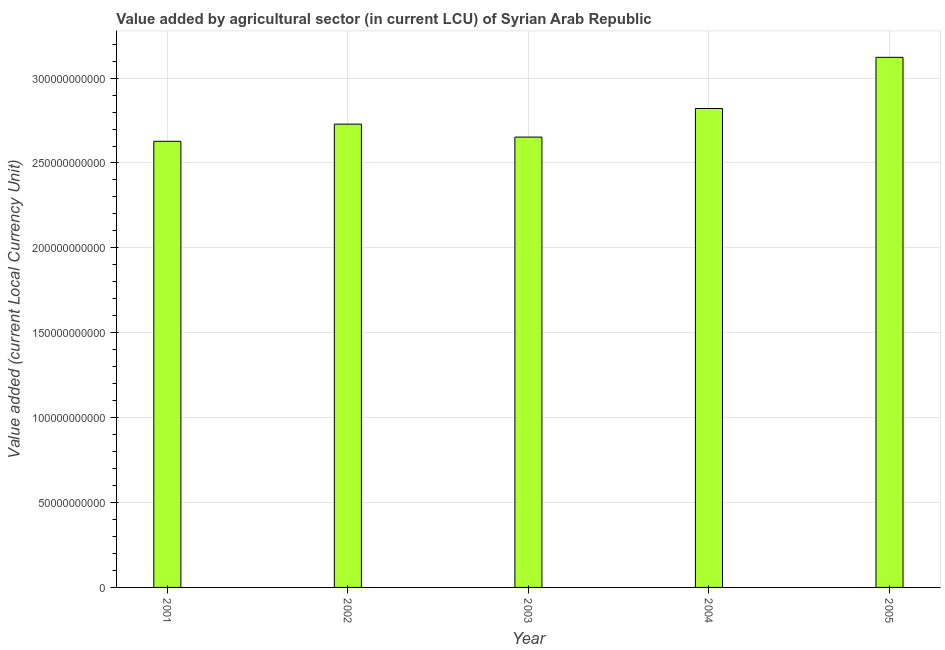Does the graph contain any zero values?
Provide a short and direct response. No. What is the title of the graph?
Give a very brief answer. Value added by agricultural sector (in current LCU) of Syrian Arab Republic. What is the label or title of the Y-axis?
Make the answer very short. Value added (current Local Currency Unit). What is the value added by agriculture sector in 2004?
Offer a terse response. 2.82e+11. Across all years, what is the maximum value added by agriculture sector?
Give a very brief answer. 3.12e+11. Across all years, what is the minimum value added by agriculture sector?
Offer a very short reply. 2.63e+11. What is the sum of the value added by agriculture sector?
Give a very brief answer. 1.40e+12. What is the difference between the value added by agriculture sector in 2001 and 2005?
Provide a short and direct response. -4.95e+1. What is the average value added by agriculture sector per year?
Your answer should be compact. 2.79e+11. What is the median value added by agriculture sector?
Make the answer very short. 2.73e+11. Do a majority of the years between 2003 and 2005 (inclusive) have value added by agriculture sector greater than 310000000000 LCU?
Provide a short and direct response. No. Is the difference between the value added by agriculture sector in 2001 and 2005 greater than the difference between any two years?
Your answer should be very brief. Yes. What is the difference between the highest and the second highest value added by agriculture sector?
Provide a succinct answer. 3.01e+1. What is the difference between the highest and the lowest value added by agriculture sector?
Offer a very short reply. 4.95e+1. How many bars are there?
Ensure brevity in your answer.  5. How many years are there in the graph?
Your answer should be very brief. 5. What is the Value added (current Local Currency Unit) of 2001?
Your response must be concise. 2.63e+11. What is the Value added (current Local Currency Unit) in 2002?
Offer a very short reply. 2.73e+11. What is the Value added (current Local Currency Unit) of 2003?
Give a very brief answer. 2.65e+11. What is the Value added (current Local Currency Unit) in 2004?
Your answer should be compact. 2.82e+11. What is the Value added (current Local Currency Unit) in 2005?
Provide a short and direct response. 3.12e+11. What is the difference between the Value added (current Local Currency Unit) in 2001 and 2002?
Give a very brief answer. -1.01e+1. What is the difference between the Value added (current Local Currency Unit) in 2001 and 2003?
Give a very brief answer. -2.47e+09. What is the difference between the Value added (current Local Currency Unit) in 2001 and 2004?
Provide a short and direct response. -1.93e+1. What is the difference between the Value added (current Local Currency Unit) in 2001 and 2005?
Keep it short and to the point. -4.95e+1. What is the difference between the Value added (current Local Currency Unit) in 2002 and 2003?
Offer a terse response. 7.63e+09. What is the difference between the Value added (current Local Currency Unit) in 2002 and 2004?
Ensure brevity in your answer.  -9.21e+09. What is the difference between the Value added (current Local Currency Unit) in 2002 and 2005?
Provide a short and direct response. -3.94e+1. What is the difference between the Value added (current Local Currency Unit) in 2003 and 2004?
Your answer should be very brief. -1.68e+1. What is the difference between the Value added (current Local Currency Unit) in 2003 and 2005?
Your answer should be compact. -4.70e+1. What is the difference between the Value added (current Local Currency Unit) in 2004 and 2005?
Your response must be concise. -3.01e+1. What is the ratio of the Value added (current Local Currency Unit) in 2001 to that in 2003?
Your answer should be compact. 0.99. What is the ratio of the Value added (current Local Currency Unit) in 2001 to that in 2004?
Offer a terse response. 0.93. What is the ratio of the Value added (current Local Currency Unit) in 2001 to that in 2005?
Offer a terse response. 0.84. What is the ratio of the Value added (current Local Currency Unit) in 2002 to that in 2005?
Provide a succinct answer. 0.87. What is the ratio of the Value added (current Local Currency Unit) in 2003 to that in 2004?
Make the answer very short. 0.94. What is the ratio of the Value added (current Local Currency Unit) in 2003 to that in 2005?
Give a very brief answer. 0.85. What is the ratio of the Value added (current Local Currency Unit) in 2004 to that in 2005?
Ensure brevity in your answer.  0.9. 